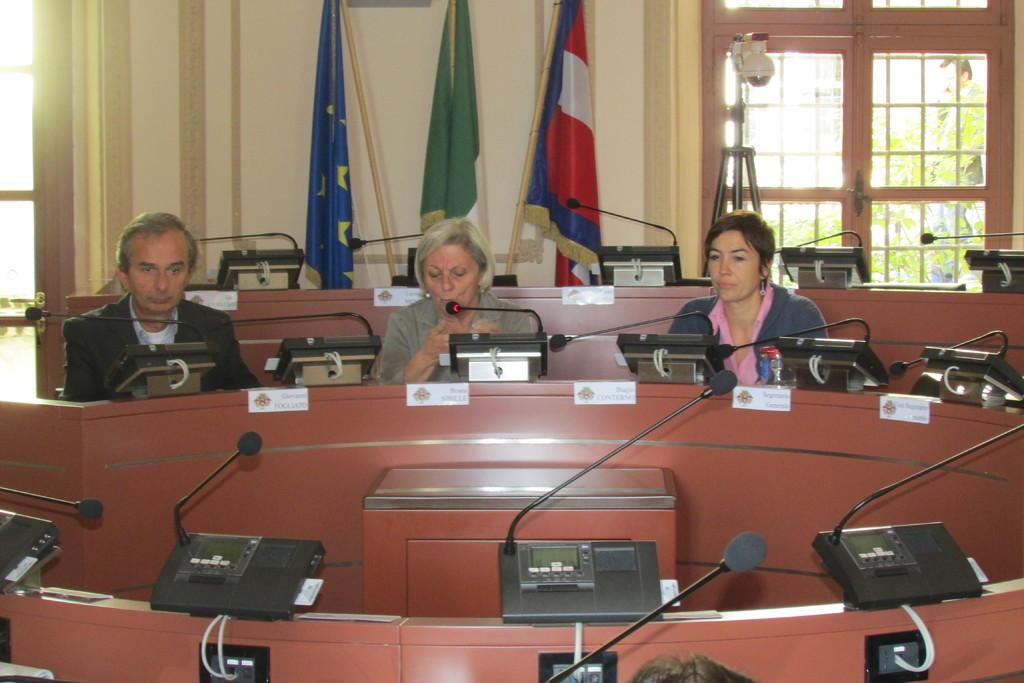How many people are in the image? There are two women and a man in the image. What are they doing in the image? They are sitting at a long table. What objects can be seen on the table? There is a telephone and a microphone attached to the table. What can be seen in the background of the image? There are three flags and a big window visible in the background. How does the wilderness affect the conversation between the people in the image? There is no wilderness present in the image; it is an indoor setting with a table, telephone, and microphone. 